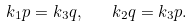<formula> <loc_0><loc_0><loc_500><loc_500>k _ { 1 } p = k _ { 3 } q , \quad k _ { 2 } q = k _ { 3 } p .</formula> 